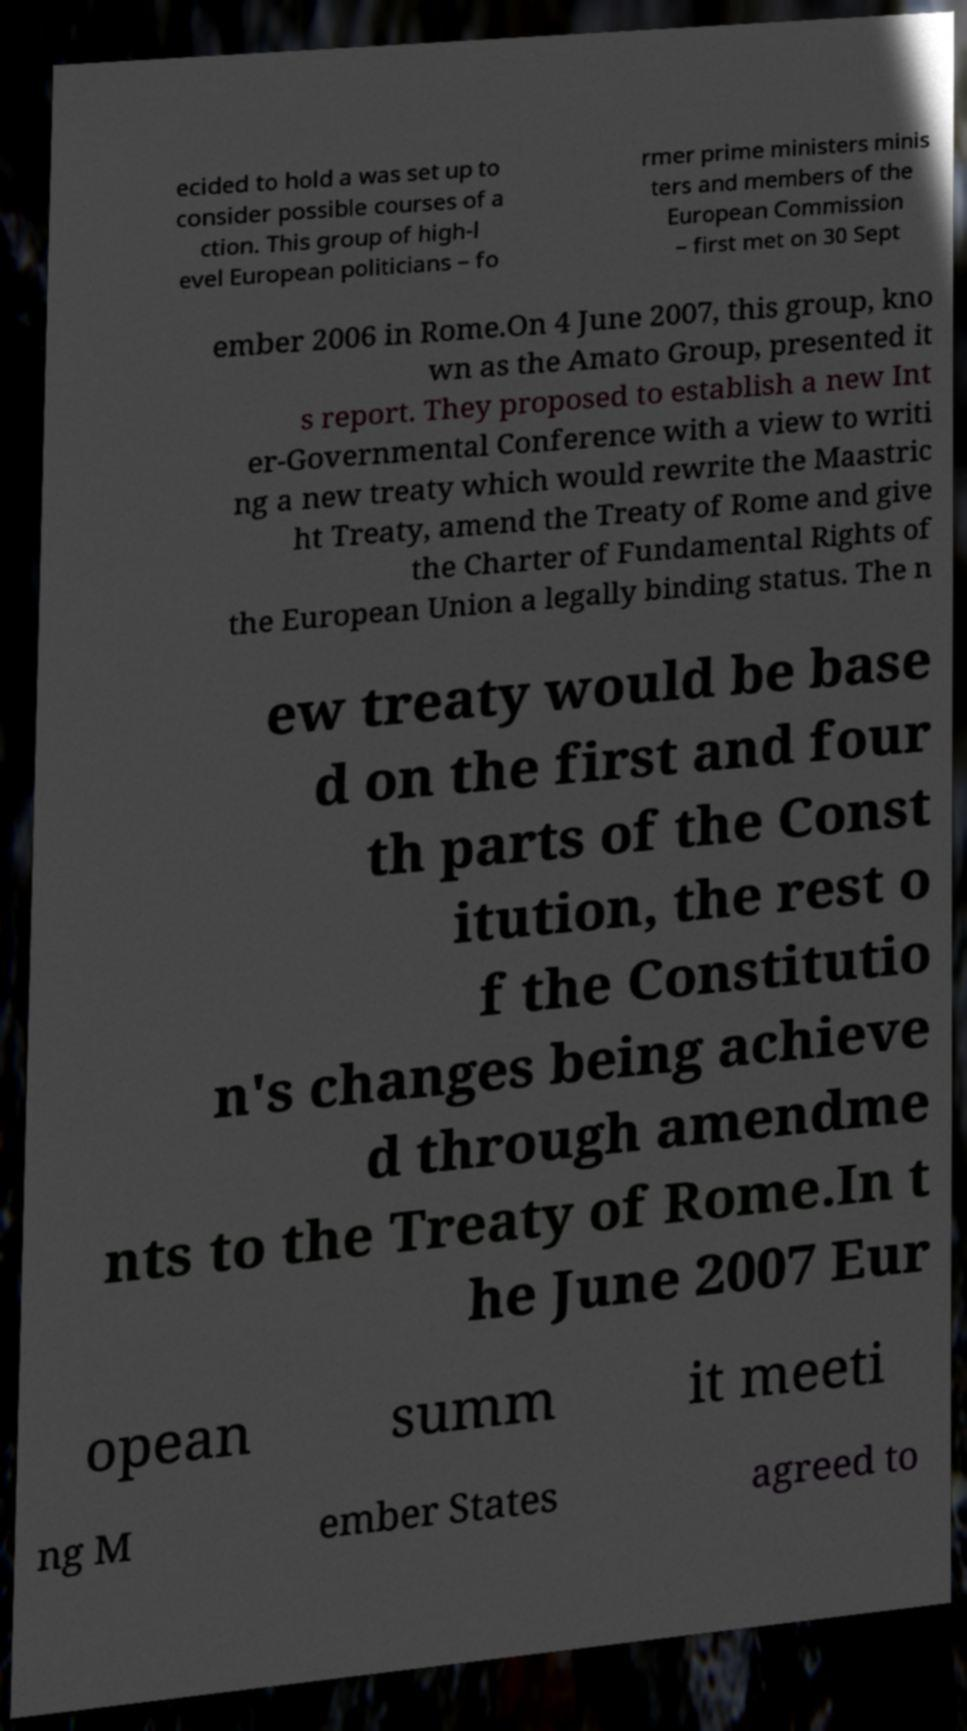Please identify and transcribe the text found in this image. ecided to hold a was set up to consider possible courses of a ction. This group of high-l evel European politicians – fo rmer prime ministers minis ters and members of the European Commission – first met on 30 Sept ember 2006 in Rome.On 4 June 2007, this group, kno wn as the Amato Group, presented it s report. They proposed to establish a new Int er-Governmental Conference with a view to writi ng a new treaty which would rewrite the Maastric ht Treaty, amend the Treaty of Rome and give the Charter of Fundamental Rights of the European Union a legally binding status. The n ew treaty would be base d on the first and four th parts of the Const itution, the rest o f the Constitutio n's changes being achieve d through amendme nts to the Treaty of Rome.In t he June 2007 Eur opean summ it meeti ng M ember States agreed to 